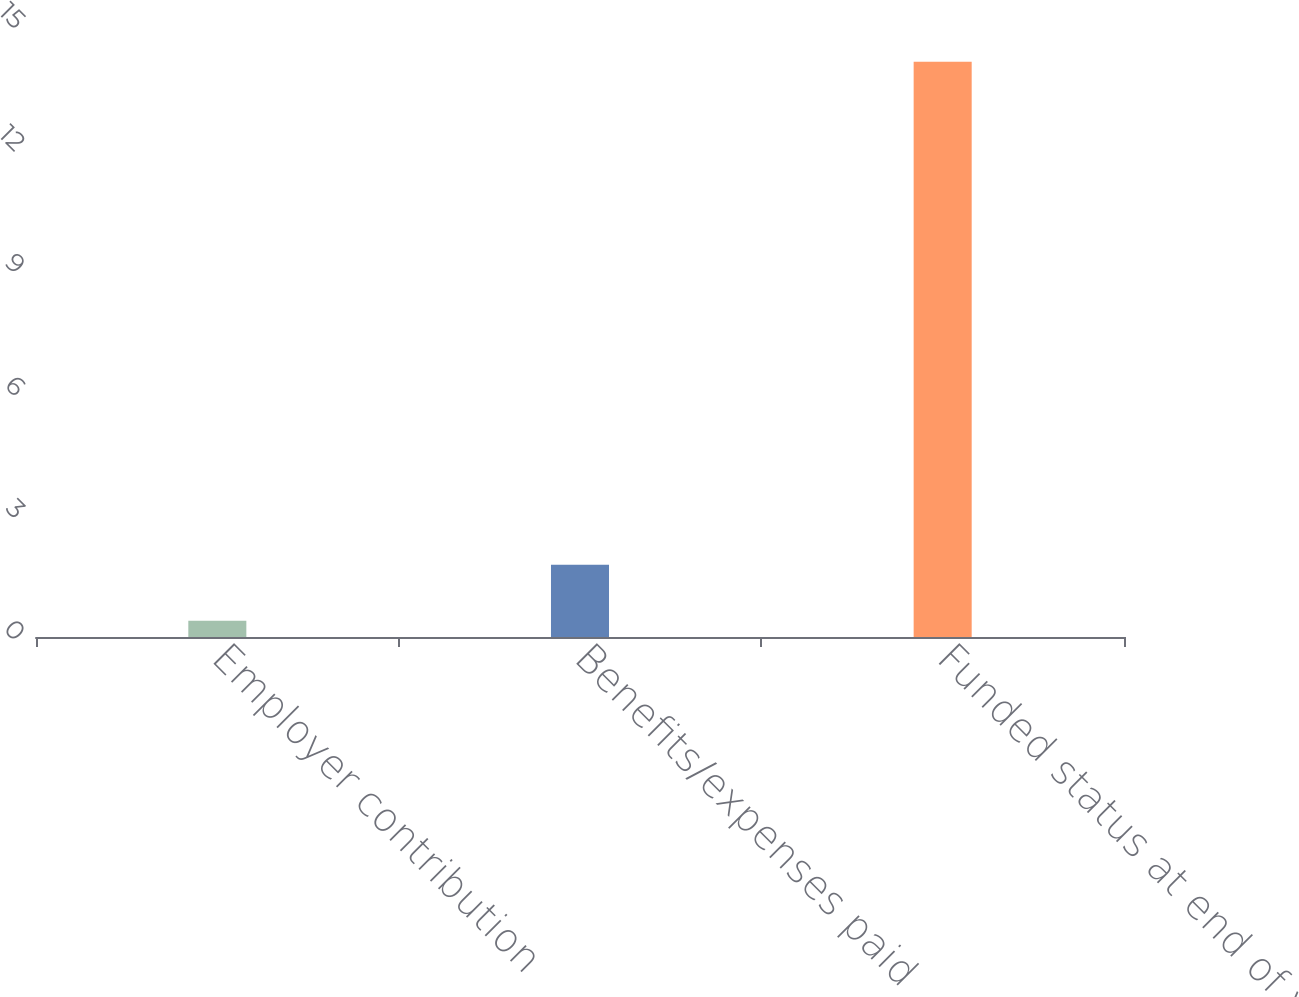Convert chart to OTSL. <chart><loc_0><loc_0><loc_500><loc_500><bar_chart><fcel>Employer contribution<fcel>Benefits/expenses paid<fcel>Funded status at end of year<nl><fcel>0.4<fcel>1.77<fcel>14.1<nl></chart> 